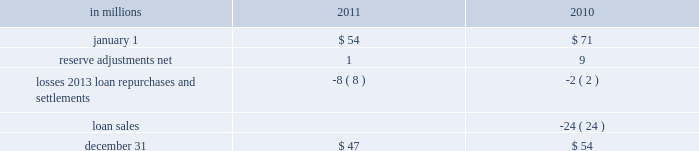Recourse and repurchase obligations as discussed in note 3 loans sale and servicing activities and variable interest entities , pnc has sold commercial mortgage and residential mortgage loans directly or indirectly in securitizations and whole-loan sale transactions with continuing involvement .
One form of continuing involvement includes certain recourse and loan repurchase obligations associated with the transferred assets in these transactions .
Commercial mortgage loan recourse obligations we originate , close and service certain multi-family commercial mortgage loans which are sold to fnma under fnma 2019s dus program .
We participated in a similar program with the fhlmc .
Under these programs , we generally assume up to a one-third pari passu risk of loss on unpaid principal balances through a loss share arrangement .
At december 31 , 2011 and december 31 , 2010 , the unpaid principal balance outstanding of loans sold as a participant in these programs was $ 13.0 billion and $ 13.2 billion , respectively .
The potential maximum exposure under the loss share arrangements was $ 4.0 billion at both december 31 , 2011 and december 31 , 2010 .
We maintain a reserve for estimated losses based upon our exposure .
The reserve for losses under these programs totaled $ 47 million and $ 54 million as of december 31 , 2011 and december 31 , 2010 , respectively , and is included in other liabilities on our consolidated balance sheet .
If payment is required under these programs , we would not have a contractual interest in the collateral underlying the mortgage loans on which losses occurred , although the value of the collateral is taken into account in determining our share of such losses .
Our exposure and activity associated with these recourse obligations are reported in the corporate & institutional banking segment .
Analysis of commercial mortgage recourse obligations .
Residential mortgage loan and home equity repurchase obligations while residential mortgage loans are sold on a non-recourse basis , we assume certain loan repurchase obligations associated with mortgage loans we have sold to investors .
These loan repurchase obligations primarily relate to situations where pnc is alleged to have breached certain origination covenants and representations and warranties made to purchasers of the loans in the respective purchase and sale agreements .
Residential mortgage loans covered by these loan repurchase obligations include first and second-lien mortgage loans we have sold through agency securitizations , non-agency securitizations , and whole-loan sale transactions .
As discussed in note 3 in this report , agency securitizations consist of mortgage loans sale transactions with fnma , fhlmc , and gnma , while non-agency securitizations and whole-loan sale transactions consist of mortgage loans sale transactions with private investors .
Our historical exposure and activity associated with agency securitization repurchase obligations has primarily been related to transactions with fnma and fhlmc , as indemnification and repurchase losses associated with fha and va-insured and uninsured loans pooled in gnma securitizations historically have been minimal .
Repurchase obligation activity associated with residential mortgages is reported in the residential mortgage banking segment .
Pnc 2019s repurchase obligations also include certain brokered home equity loans/lines that were sold to a limited number of private investors in the financial services industry by national city prior to our acquisition .
Pnc is no longer engaged in the brokered home equity lending business , and our exposure under these loan repurchase obligations is limited to repurchases of whole-loans sold in these transactions .
Repurchase activity associated with brokered home equity loans/lines is reported in the non-strategic assets portfolio segment .
Loan covenants and representations and warranties are established through loan sale agreements with various investors to provide assurance that pnc has sold loans to investors of sufficient investment quality .
Key aspects of such covenants and representations and warranties include the loan 2019s compliance with any applicable loan criteria established by the investor , including underwriting standards , delivery of all required loan documents to the investor or its designated party , sufficient collateral valuation , and the validity of the lien securing the loan .
As a result of alleged breaches of these contractual obligations , investors may request pnc to indemnify them against losses on certain loans or to repurchase loans .
These investor indemnification or repurchase claims are typically settled on an individual loan basis through make- whole payments or loan repurchases ; however , on occasion we may negotiate pooled settlements with investors .
Indemnifications for loss or loan repurchases typically occur when , after review of the claim , we agree insufficient evidence exists to dispute the investor 2019s claim that a breach of a loan covenant and representation and warranty has occurred , such breach has not been cured , and the effect of such breach is deemed to have had a material and adverse effect on the value of the transferred loan .
Depending on the sale agreement and upon proper notice from the investor , we typically respond to such indemnification and repurchase requests within 60 days , although final resolution of the claim may take a longer period of time .
With the exception of the sales the pnc financial services group , inc .
2013 form 10-k 199 .
What was percentage of potential maximum exposure loss at dec 31 , 2011? 
Computations: (4 / 13.0)
Answer: 0.30769. Recourse and repurchase obligations as discussed in note 3 loans sale and servicing activities and variable interest entities , pnc has sold commercial mortgage and residential mortgage loans directly or indirectly in securitizations and whole-loan sale transactions with continuing involvement .
One form of continuing involvement includes certain recourse and loan repurchase obligations associated with the transferred assets in these transactions .
Commercial mortgage loan recourse obligations we originate , close and service certain multi-family commercial mortgage loans which are sold to fnma under fnma 2019s dus program .
We participated in a similar program with the fhlmc .
Under these programs , we generally assume up to a one-third pari passu risk of loss on unpaid principal balances through a loss share arrangement .
At december 31 , 2011 and december 31 , 2010 , the unpaid principal balance outstanding of loans sold as a participant in these programs was $ 13.0 billion and $ 13.2 billion , respectively .
The potential maximum exposure under the loss share arrangements was $ 4.0 billion at both december 31 , 2011 and december 31 , 2010 .
We maintain a reserve for estimated losses based upon our exposure .
The reserve for losses under these programs totaled $ 47 million and $ 54 million as of december 31 , 2011 and december 31 , 2010 , respectively , and is included in other liabilities on our consolidated balance sheet .
If payment is required under these programs , we would not have a contractual interest in the collateral underlying the mortgage loans on which losses occurred , although the value of the collateral is taken into account in determining our share of such losses .
Our exposure and activity associated with these recourse obligations are reported in the corporate & institutional banking segment .
Analysis of commercial mortgage recourse obligations .
Residential mortgage loan and home equity repurchase obligations while residential mortgage loans are sold on a non-recourse basis , we assume certain loan repurchase obligations associated with mortgage loans we have sold to investors .
These loan repurchase obligations primarily relate to situations where pnc is alleged to have breached certain origination covenants and representations and warranties made to purchasers of the loans in the respective purchase and sale agreements .
Residential mortgage loans covered by these loan repurchase obligations include first and second-lien mortgage loans we have sold through agency securitizations , non-agency securitizations , and whole-loan sale transactions .
As discussed in note 3 in this report , agency securitizations consist of mortgage loans sale transactions with fnma , fhlmc , and gnma , while non-agency securitizations and whole-loan sale transactions consist of mortgage loans sale transactions with private investors .
Our historical exposure and activity associated with agency securitization repurchase obligations has primarily been related to transactions with fnma and fhlmc , as indemnification and repurchase losses associated with fha and va-insured and uninsured loans pooled in gnma securitizations historically have been minimal .
Repurchase obligation activity associated with residential mortgages is reported in the residential mortgage banking segment .
Pnc 2019s repurchase obligations also include certain brokered home equity loans/lines that were sold to a limited number of private investors in the financial services industry by national city prior to our acquisition .
Pnc is no longer engaged in the brokered home equity lending business , and our exposure under these loan repurchase obligations is limited to repurchases of whole-loans sold in these transactions .
Repurchase activity associated with brokered home equity loans/lines is reported in the non-strategic assets portfolio segment .
Loan covenants and representations and warranties are established through loan sale agreements with various investors to provide assurance that pnc has sold loans to investors of sufficient investment quality .
Key aspects of such covenants and representations and warranties include the loan 2019s compliance with any applicable loan criteria established by the investor , including underwriting standards , delivery of all required loan documents to the investor or its designated party , sufficient collateral valuation , and the validity of the lien securing the loan .
As a result of alleged breaches of these contractual obligations , investors may request pnc to indemnify them against losses on certain loans or to repurchase loans .
These investor indemnification or repurchase claims are typically settled on an individual loan basis through make- whole payments or loan repurchases ; however , on occasion we may negotiate pooled settlements with investors .
Indemnifications for loss or loan repurchases typically occur when , after review of the claim , we agree insufficient evidence exists to dispute the investor 2019s claim that a breach of a loan covenant and representation and warranty has occurred , such breach has not been cured , and the effect of such breach is deemed to have had a material and adverse effect on the value of the transferred loan .
Depending on the sale agreement and upon proper notice from the investor , we typically respond to such indemnification and repurchase requests within 60 days , although final resolution of the claim may take a longer period of time .
With the exception of the sales the pnc financial services group , inc .
2013 form 10-k 199 .
In 2011 what was the percentage change in the commercial mortgage recourse obligations .? 
Computations: ((47 - 54) / 54)
Answer: -0.12963. 